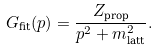<formula> <loc_0><loc_0><loc_500><loc_500>G _ { \text {fit} } ( p ) = \frac { Z _ { \text {prop} } } { p ^ { 2 } + m ^ { 2 } _ { \text {latt} } } .</formula> 